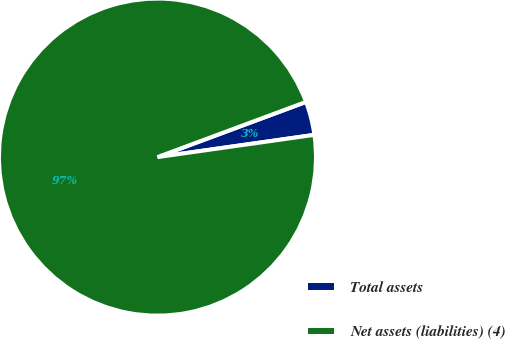Convert chart to OTSL. <chart><loc_0><loc_0><loc_500><loc_500><pie_chart><fcel>Total assets<fcel>Net assets (liabilities) (4)<nl><fcel>3.42%<fcel>96.58%<nl></chart> 